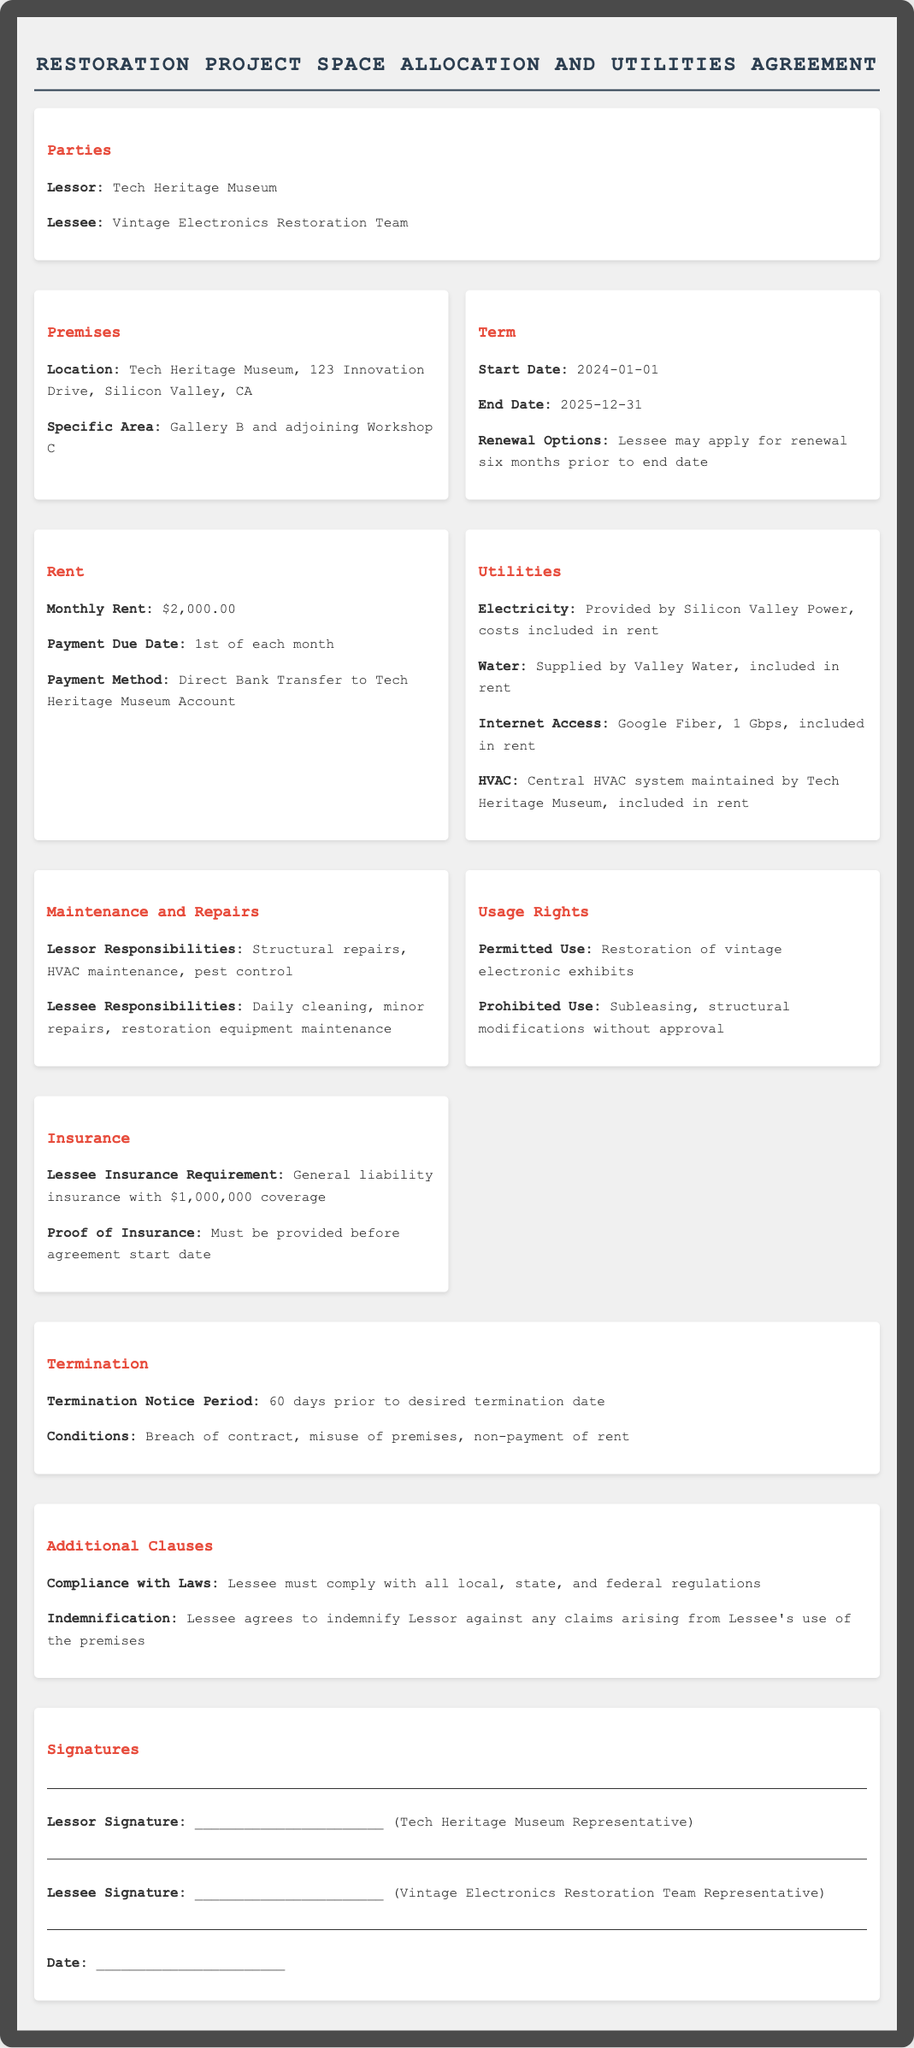What is the starting date of the lease? The starting date of the lease is mentioned in the Term section.
Answer: 2024-01-01 What is the monthly rent? The monthly rent is specified in the Rent section of the document.
Answer: $2,000.00 Who is the lessee? The lessee is identified in the Parties section.
Answer: Vintage Electronics Restoration Team What are the utilities included in the rent? The Utilities section lists the utilities provided at no additional charge.
Answer: Electricity, Water, Internet Access, HVAC What is the insurance coverage requirement for the lessee? This information is found in the Insurance section.
Answer: $1,000,000 coverage What is the termination notice period? The notice period for termination is detailed in the Termination section.
Answer: 60 days What responsibilities does the lessee have? Lessee responsibilities are outlined in the Maintenance and Repairs section.
Answer: Daily cleaning, minor repairs, restoration equipment maintenance What is the location of the premises? The location of the premises is stated in the Premises section.
Answer: Tech Heritage Museum, 123 Innovation Drive, Silicon Valley, CA What is prohibited in the usage rights? Prohibited uses are listed in the Usage Rights section.
Answer: Subleasing, structural modifications without approval 